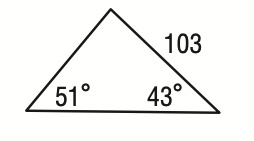Question: What is the perimeter of the triangle shown below? Round to the nearest tenth.
Choices:
A. 222.6
B. 300.6
C. 325.6
D. 377.6
Answer with the letter. Answer: C 